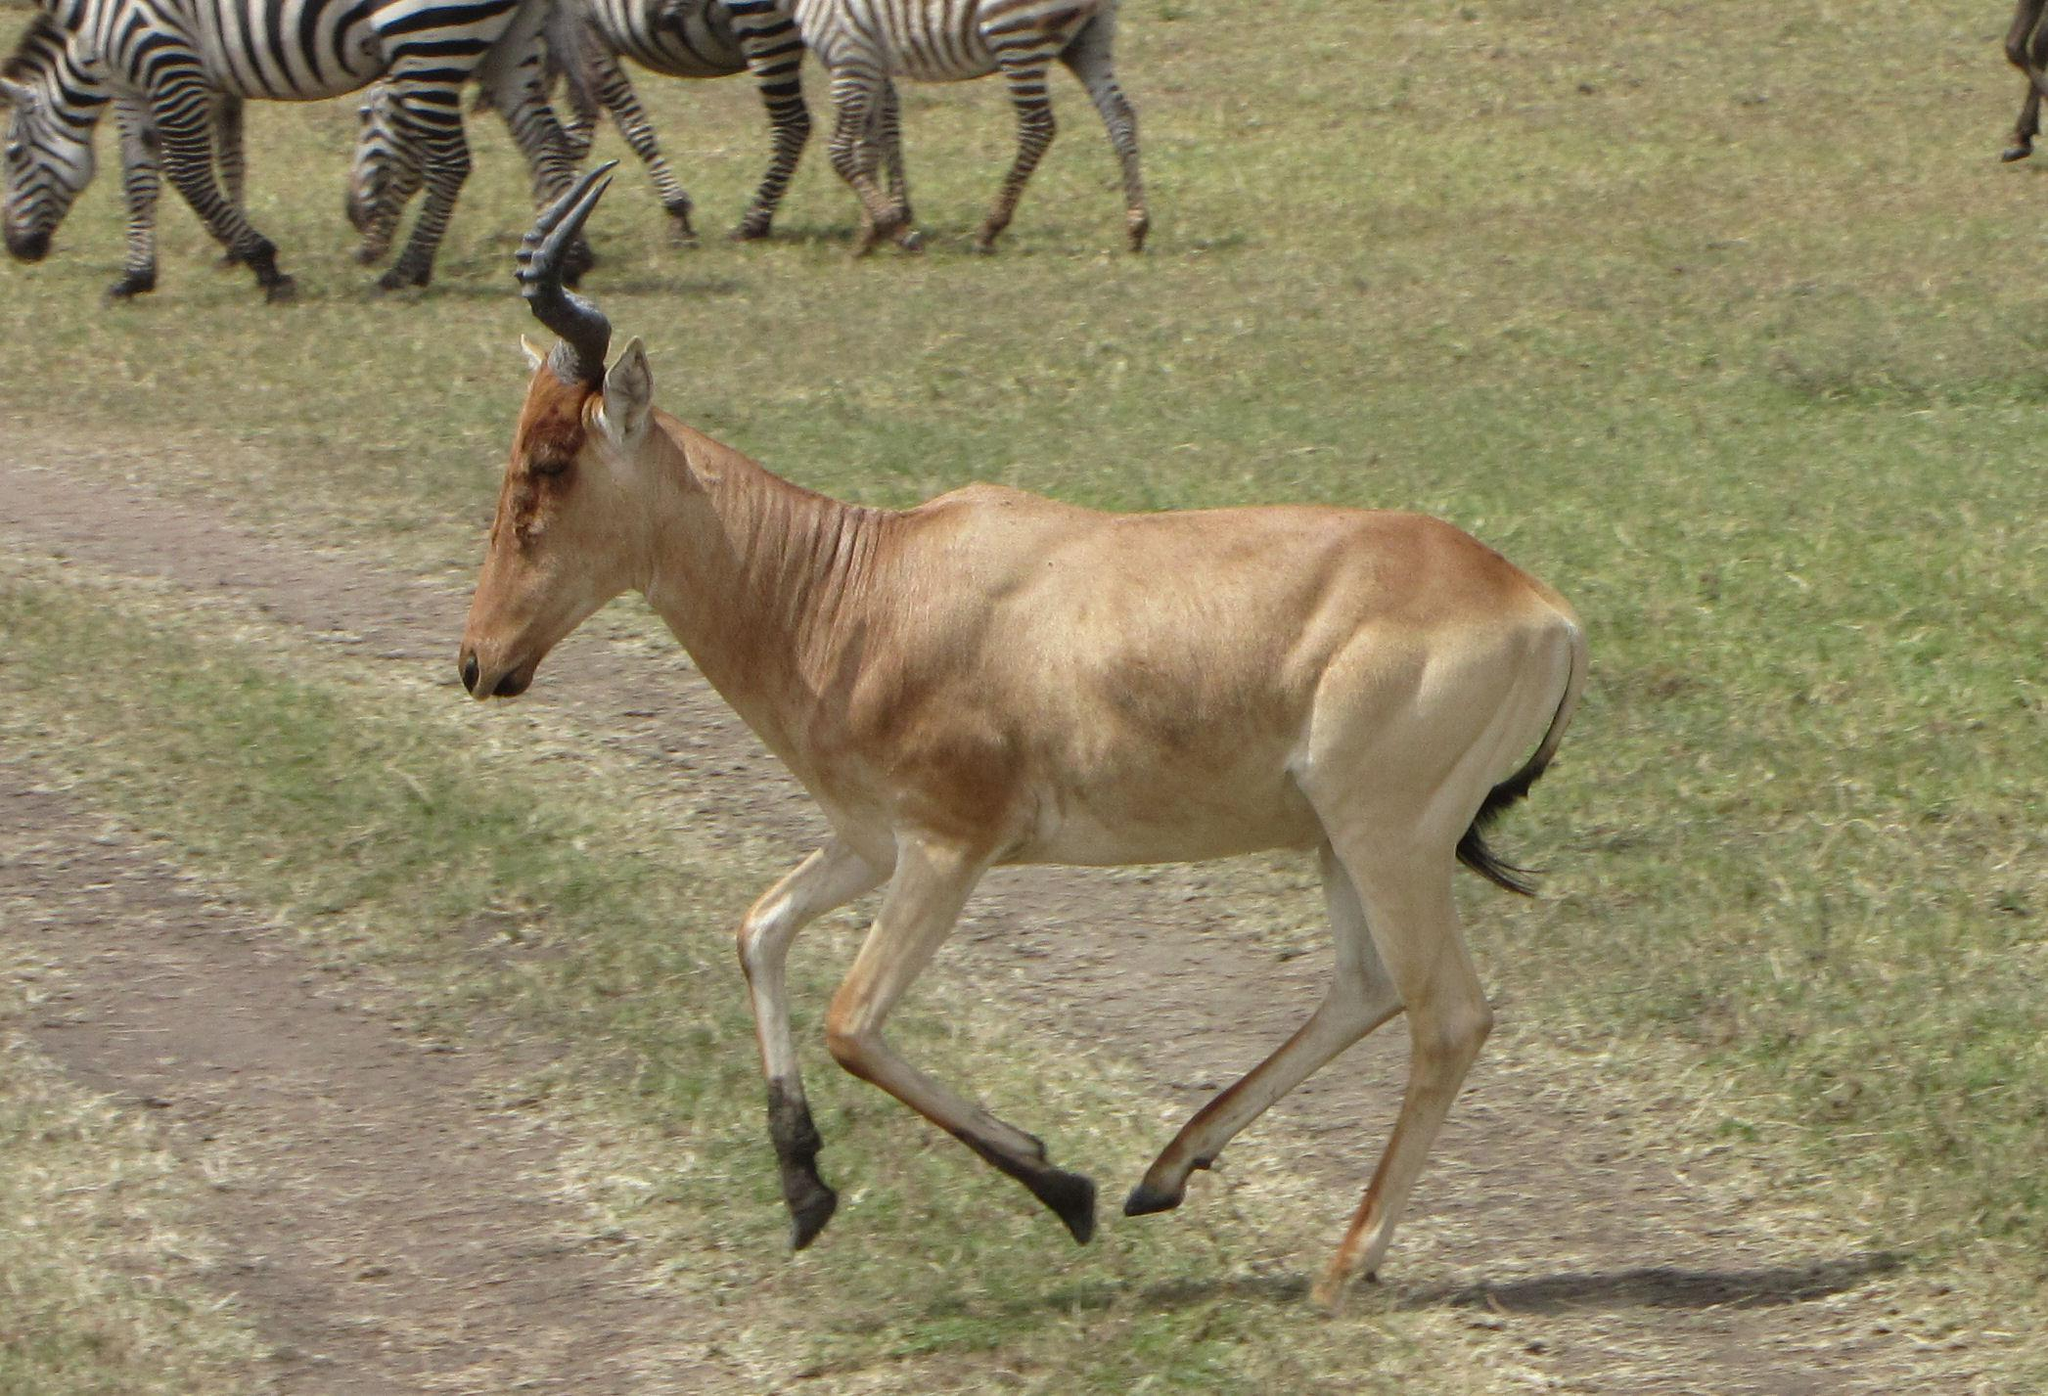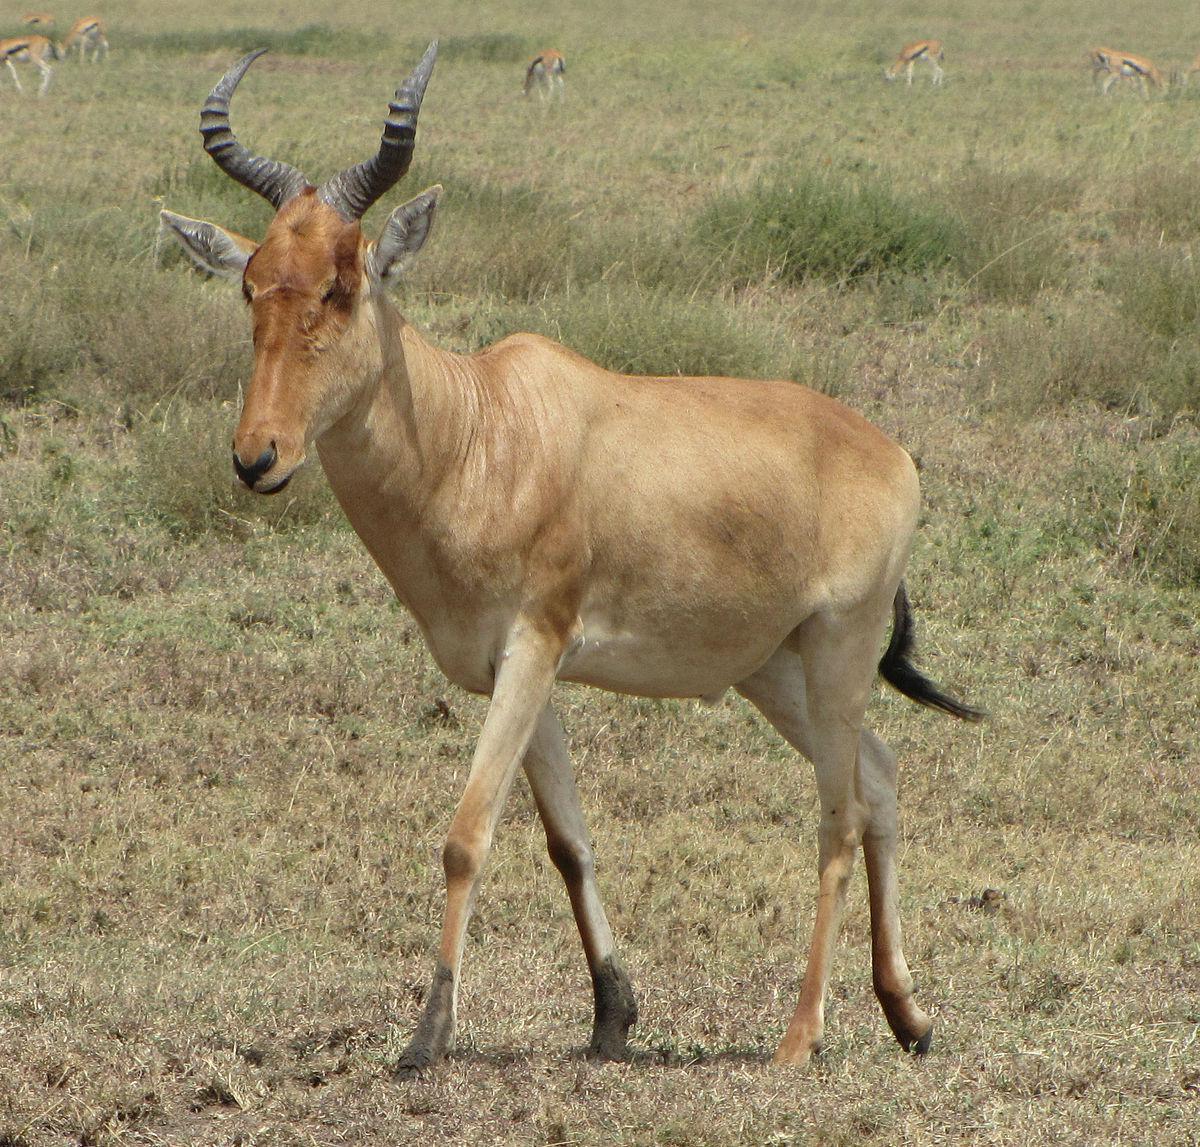The first image is the image on the left, the second image is the image on the right. Examine the images to the left and right. Is the description "Each image contains exactly one antelope facing in the same direction." accurate? Answer yes or no. Yes. 